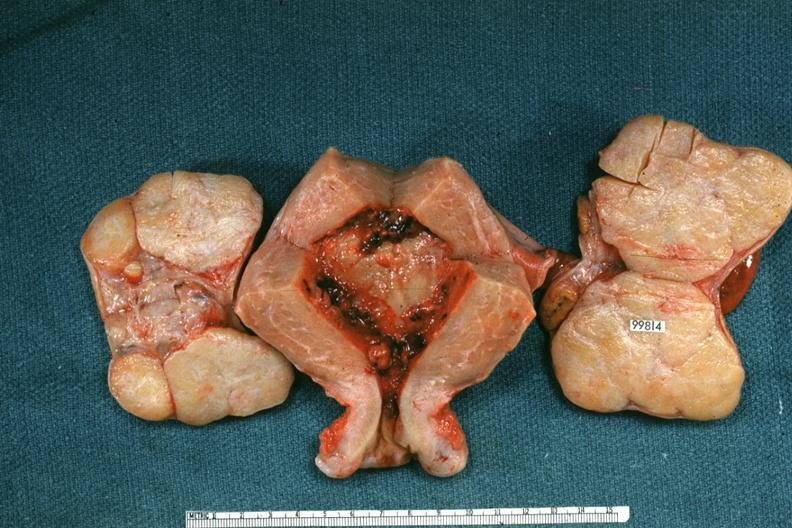s muscle atrophy present?
Answer the question using a single word or phrase. No 